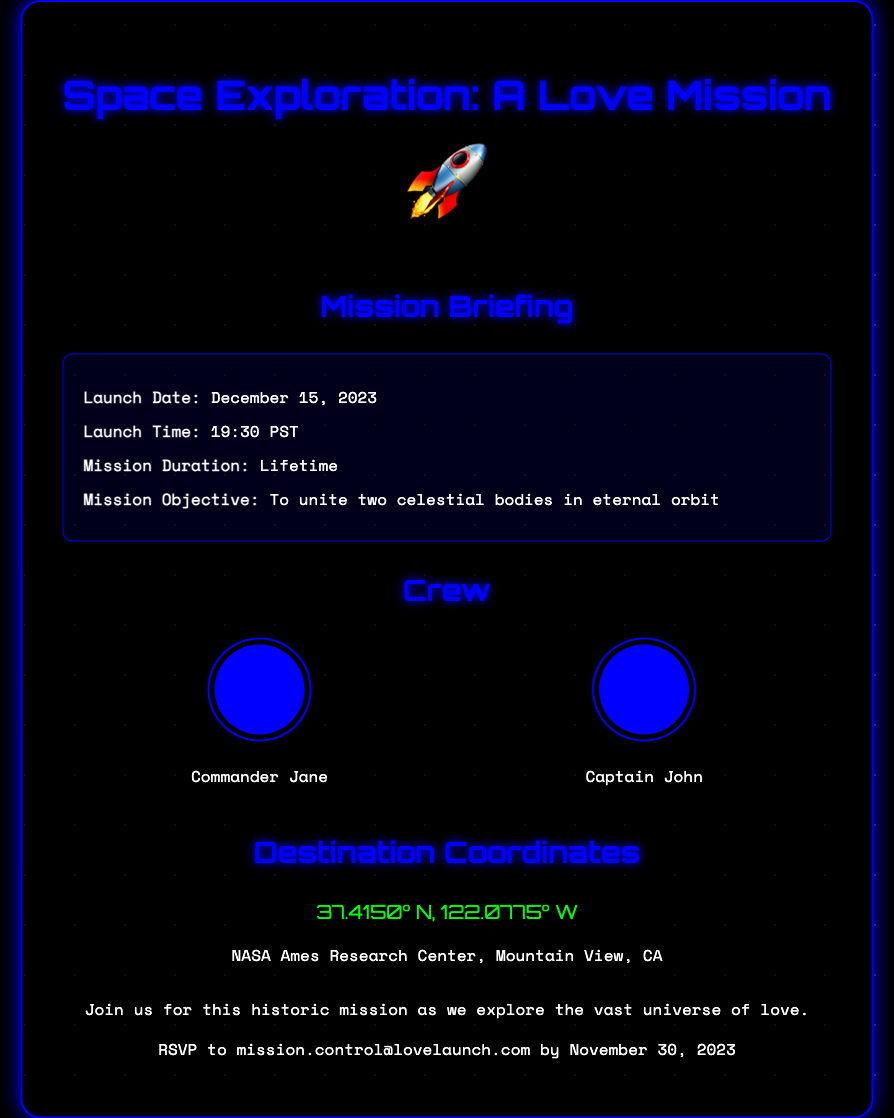what is the launch date? The launch date is specified in the mission briefing section of the document.
Answer: December 15, 2023 what is the launch time? The launch time is provided in the mission briefing section.
Answer: 19:30 PST who is the commander? The document lists the crew of the mission and identifies one member as the commander.
Answer: Commander Jane what is the mission objective? The mission objective is stated in the mission briefing section and describes the purpose of the event.
Answer: To unite two celestial bodies in eternal orbit where is the destination? The destination coordinates and location are provided in the invitation.
Answer: NASA Ames Research Center, Mountain View, CA what is the mission duration? The mission duration is mentioned in the mission briefing and indicates how long the journey will last.
Answer: Lifetime who is the captain? The document specifies the roles of the crew members, including the captain.
Answer: Captain John when is the RSVP deadline? The RSVP deadline is outlined towards the end of the document.
Answer: November 30, 2023 